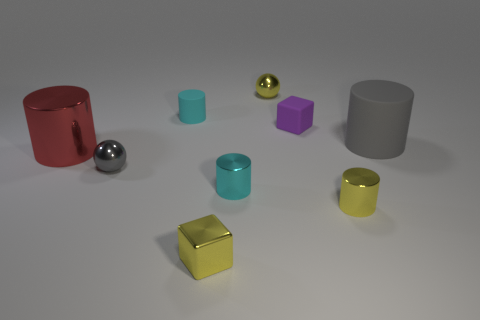Is there anything else that has the same color as the big rubber cylinder?
Give a very brief answer. Yes. There is a yellow thing that is behind the purple rubber cube; what size is it?
Keep it short and to the point. Small. There is a cube that is to the right of the block in front of the big metallic object left of the yellow metal sphere; what is its size?
Keep it short and to the point. Small. The metal sphere that is on the right side of the small block in front of the gray rubber object is what color?
Give a very brief answer. Yellow. There is a tiny yellow thing that is the same shape as the big gray rubber thing; what is its material?
Your answer should be very brief. Metal. Is there any other thing that is made of the same material as the big gray cylinder?
Offer a very short reply. Yes. There is a yellow metallic cylinder; are there any yellow objects in front of it?
Provide a short and direct response. Yes. What number of tiny green matte cubes are there?
Your answer should be compact. 0. There is a big thing to the right of the yellow shiny cylinder; what number of small cylinders are behind it?
Your answer should be very brief. 1. Is the color of the matte cube the same as the big cylinder left of the small yellow metallic cube?
Your response must be concise. No. 